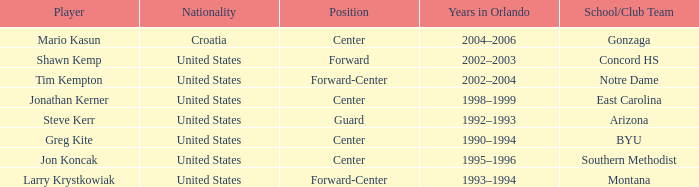What nationality has steve kerr as the player? United States. 